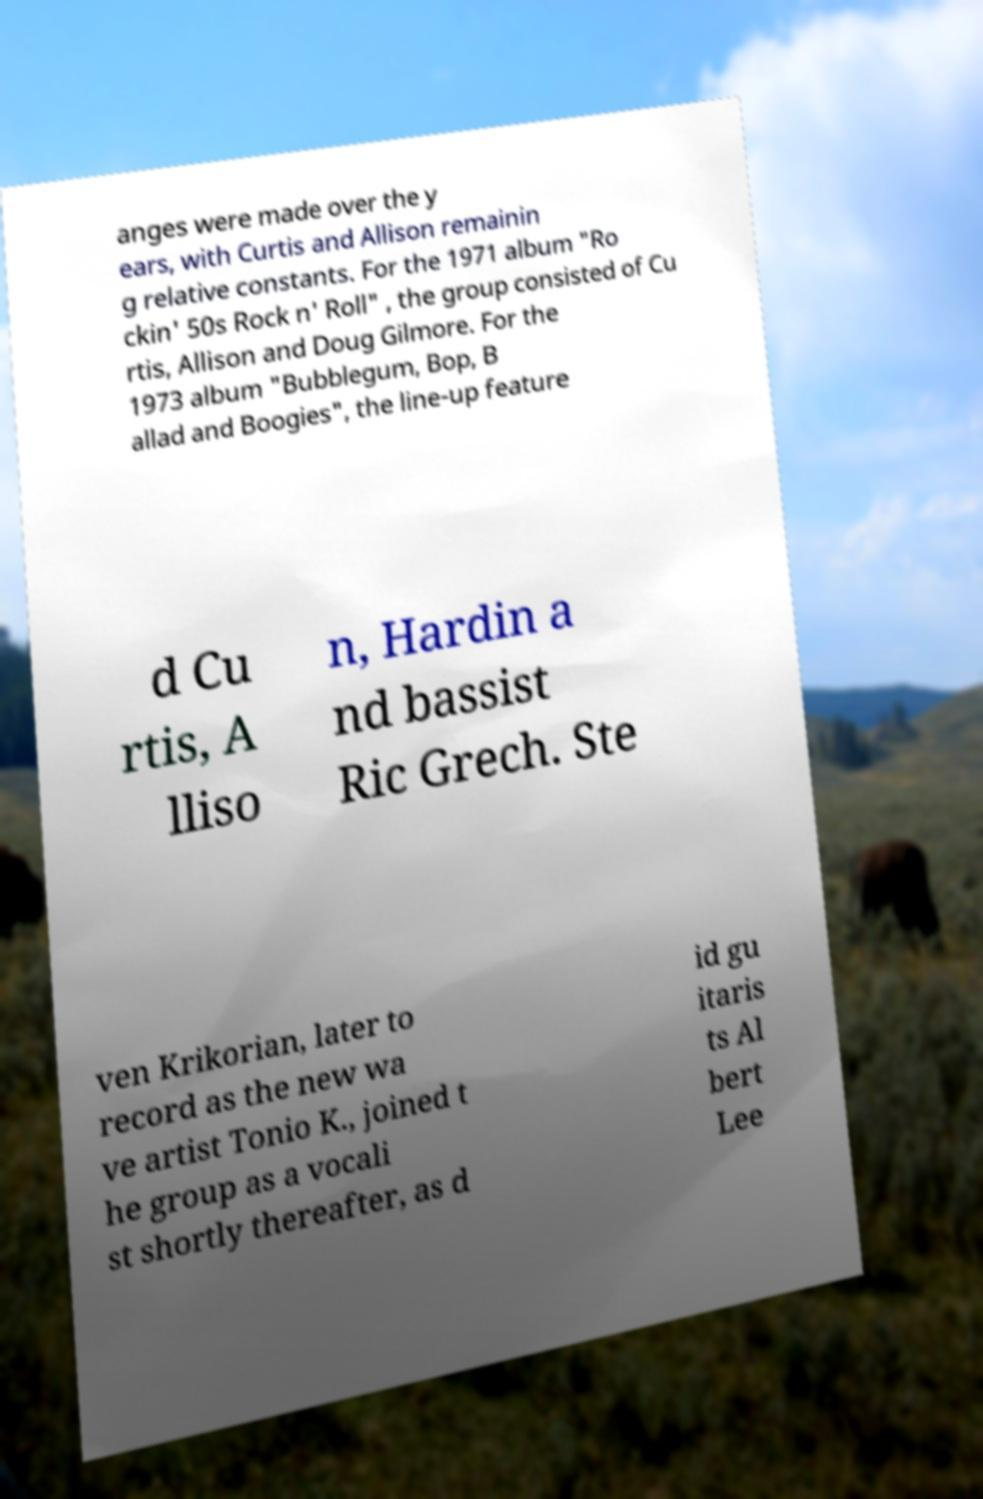Please read and relay the text visible in this image. What does it say? anges were made over the y ears, with Curtis and Allison remainin g relative constants. For the 1971 album "Ro ckin' 50s Rock n' Roll" , the group consisted of Cu rtis, Allison and Doug Gilmore. For the 1973 album "Bubblegum, Bop, B allad and Boogies", the line-up feature d Cu rtis, A lliso n, Hardin a nd bassist Ric Grech. Ste ven Krikorian, later to record as the new wa ve artist Tonio K., joined t he group as a vocali st shortly thereafter, as d id gu itaris ts Al bert Lee 